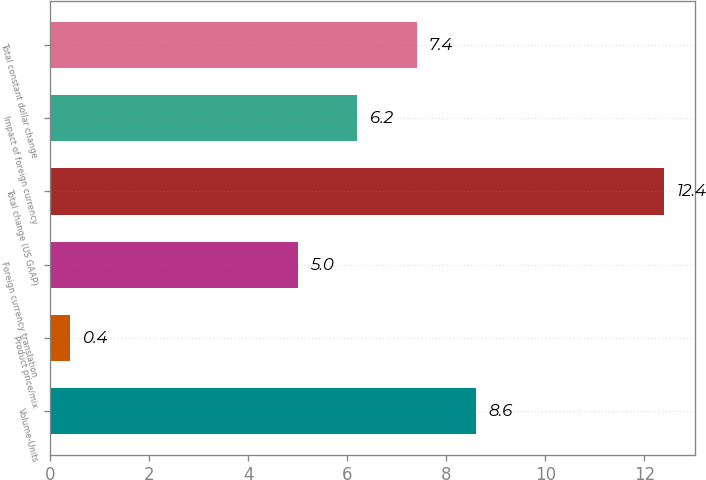<chart> <loc_0><loc_0><loc_500><loc_500><bar_chart><fcel>Volume-Units<fcel>Product price/mix<fcel>Foreign currency translation<fcel>Total change (US GAAP)<fcel>Impact of foreign currency<fcel>Total constant dollar change<nl><fcel>8.6<fcel>0.4<fcel>5<fcel>12.4<fcel>6.2<fcel>7.4<nl></chart> 